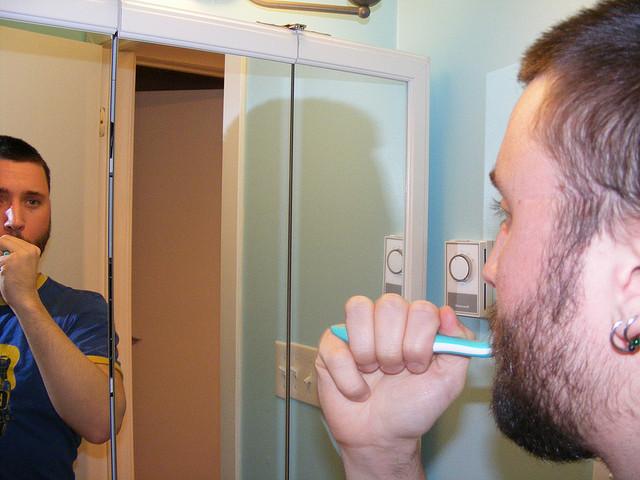What is this man looking at?
Short answer required. Reflection. Shouldn't this man shave?
Concise answer only. No. How many earrings does he have?
Be succinct. 2. 